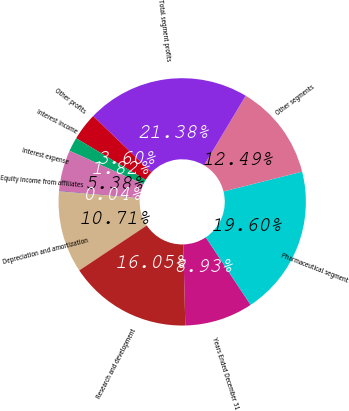<chart> <loc_0><loc_0><loc_500><loc_500><pie_chart><fcel>Years Ended December 31<fcel>Pharmaceutical segment<fcel>Other segments<fcel>Total segment profits<fcel>Other profits<fcel>Interest income<fcel>Interest expense<fcel>Equity income from affiliates<fcel>Depreciation and amortization<fcel>Research and development<nl><fcel>8.93%<fcel>19.6%<fcel>12.49%<fcel>21.38%<fcel>3.6%<fcel>1.82%<fcel>5.38%<fcel>0.04%<fcel>10.71%<fcel>16.05%<nl></chart> 